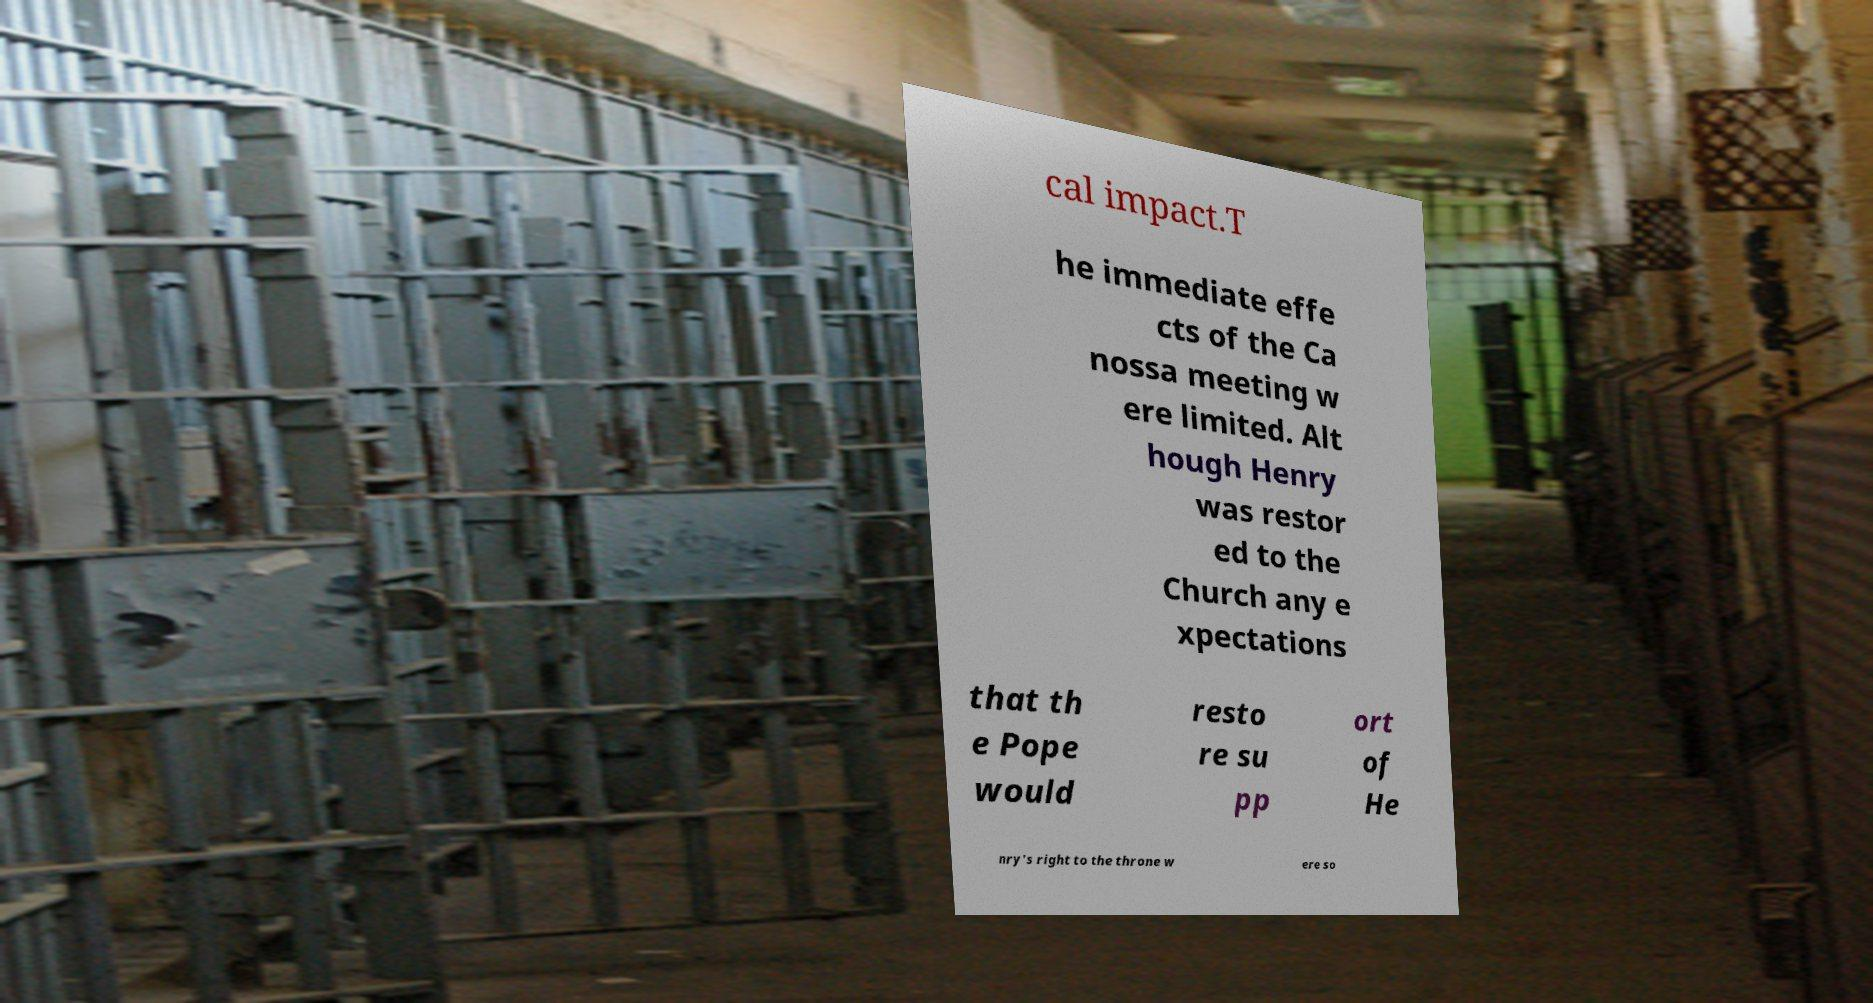What messages or text are displayed in this image? I need them in a readable, typed format. cal impact.T he immediate effe cts of the Ca nossa meeting w ere limited. Alt hough Henry was restor ed to the Church any e xpectations that th e Pope would resto re su pp ort of He nry's right to the throne w ere so 